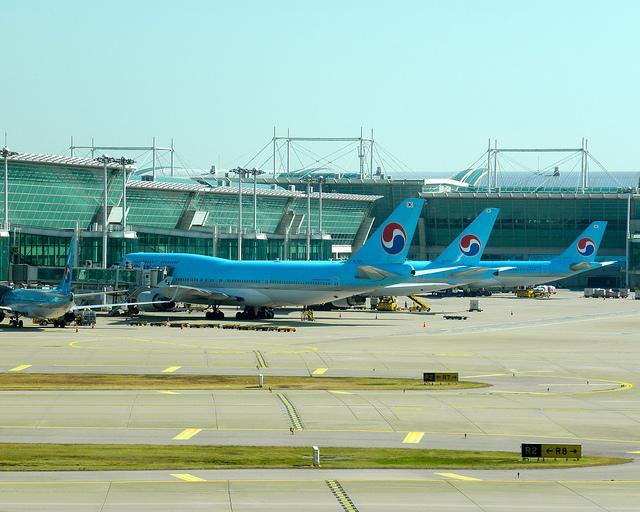The symbol on the planes looks like what logo? Please explain your reasoning. pepsi. The logo is a circle that is red, white, and blue. a soda company uses a similar logo. 